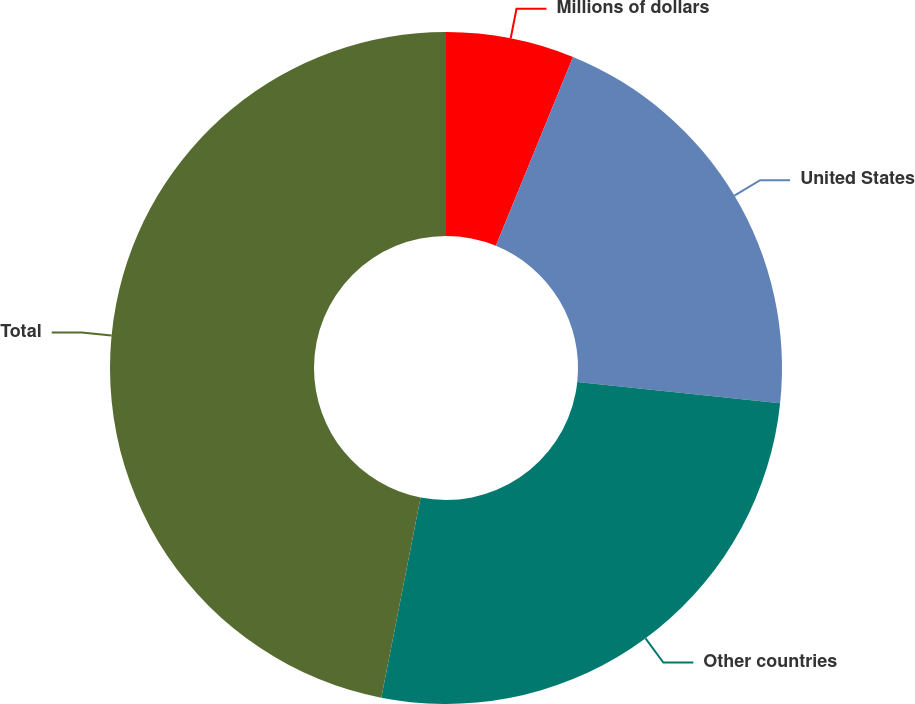Convert chart. <chart><loc_0><loc_0><loc_500><loc_500><pie_chart><fcel>Millions of dollars<fcel>United States<fcel>Other countries<fcel>Total<nl><fcel>6.17%<fcel>20.51%<fcel>26.41%<fcel>46.92%<nl></chart> 